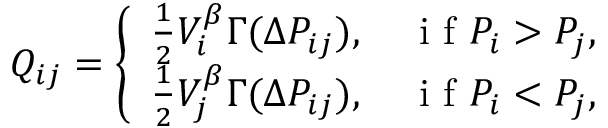<formula> <loc_0><loc_0><loc_500><loc_500>Q _ { i j } = \left \{ \begin{array} { l l } { \frac { 1 } { 2 } V _ { i } ^ { \beta } \Gamma ( \Delta P _ { i j } ) , \quad i f P _ { i } > P _ { j } , } \\ { \frac { 1 } { 2 } V _ { j } ^ { \beta } \Gamma ( \Delta P _ { i j } ) , \quad i f P _ { i } < P _ { j } , } \end{array}</formula> 